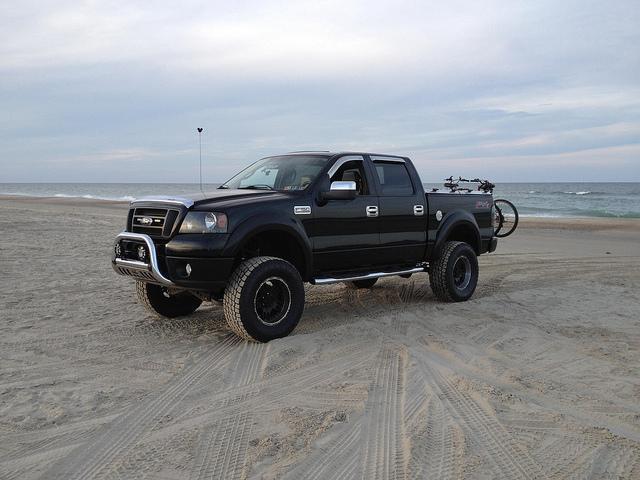How many doors does the truck have?
Give a very brief answer. 4. 